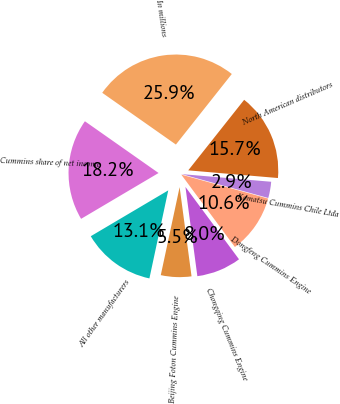<chart> <loc_0><loc_0><loc_500><loc_500><pie_chart><fcel>In millions<fcel>North American distributors<fcel>Komatsu Cummins Chile Ltda<fcel>Dongfeng Cummins Engine<fcel>Chongqing Cummins Engine<fcel>Beijing Foton Cummins Engine<fcel>All other manufacturers<fcel>Cummins share of net income<nl><fcel>25.92%<fcel>15.69%<fcel>2.92%<fcel>10.58%<fcel>8.03%<fcel>5.47%<fcel>13.14%<fcel>18.25%<nl></chart> 